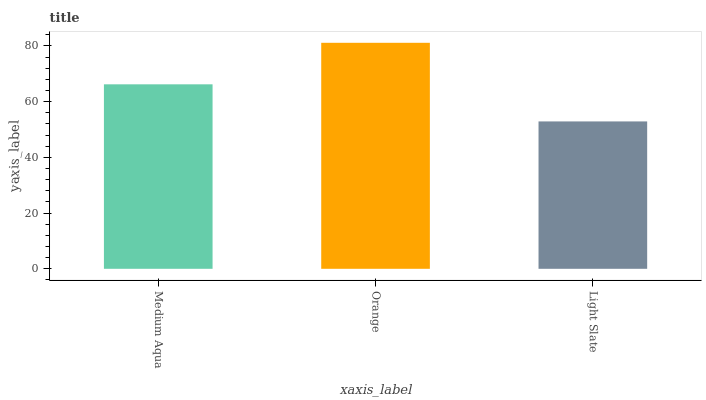Is Light Slate the minimum?
Answer yes or no. Yes. Is Orange the maximum?
Answer yes or no. Yes. Is Orange the minimum?
Answer yes or no. No. Is Light Slate the maximum?
Answer yes or no. No. Is Orange greater than Light Slate?
Answer yes or no. Yes. Is Light Slate less than Orange?
Answer yes or no. Yes. Is Light Slate greater than Orange?
Answer yes or no. No. Is Orange less than Light Slate?
Answer yes or no. No. Is Medium Aqua the high median?
Answer yes or no. Yes. Is Medium Aqua the low median?
Answer yes or no. Yes. Is Light Slate the high median?
Answer yes or no. No. Is Light Slate the low median?
Answer yes or no. No. 